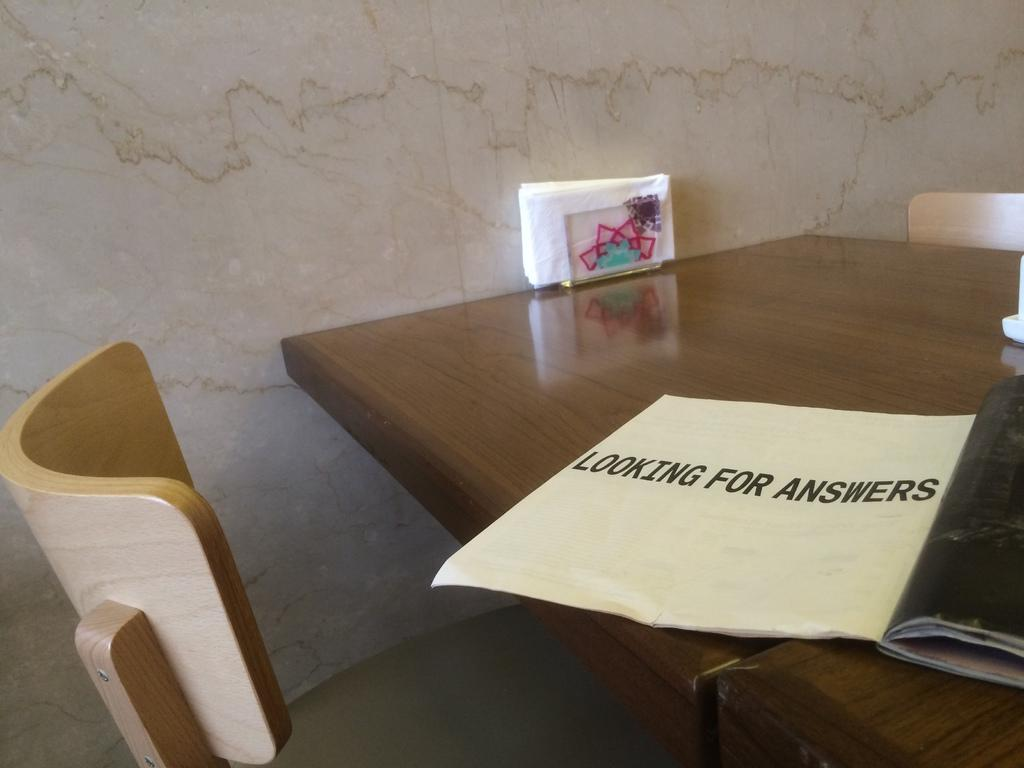How many tables are present in the image? There are two tables in the image. What are the tables used for? The tables are associated with chairs, suggesting they are used for sitting and possibly eating or working. What can be found on the tables? There are tissue papers and other objects on the tables. What is visible in the background of the image? There is a wall in the background of the image. What month is it in the image? The month cannot be determined from the image, as it does not contain any information about the time of year. 